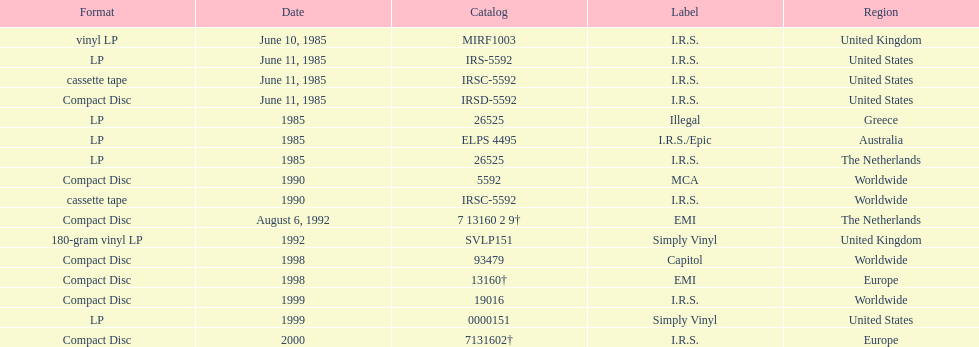How many times was the album released? 13. 